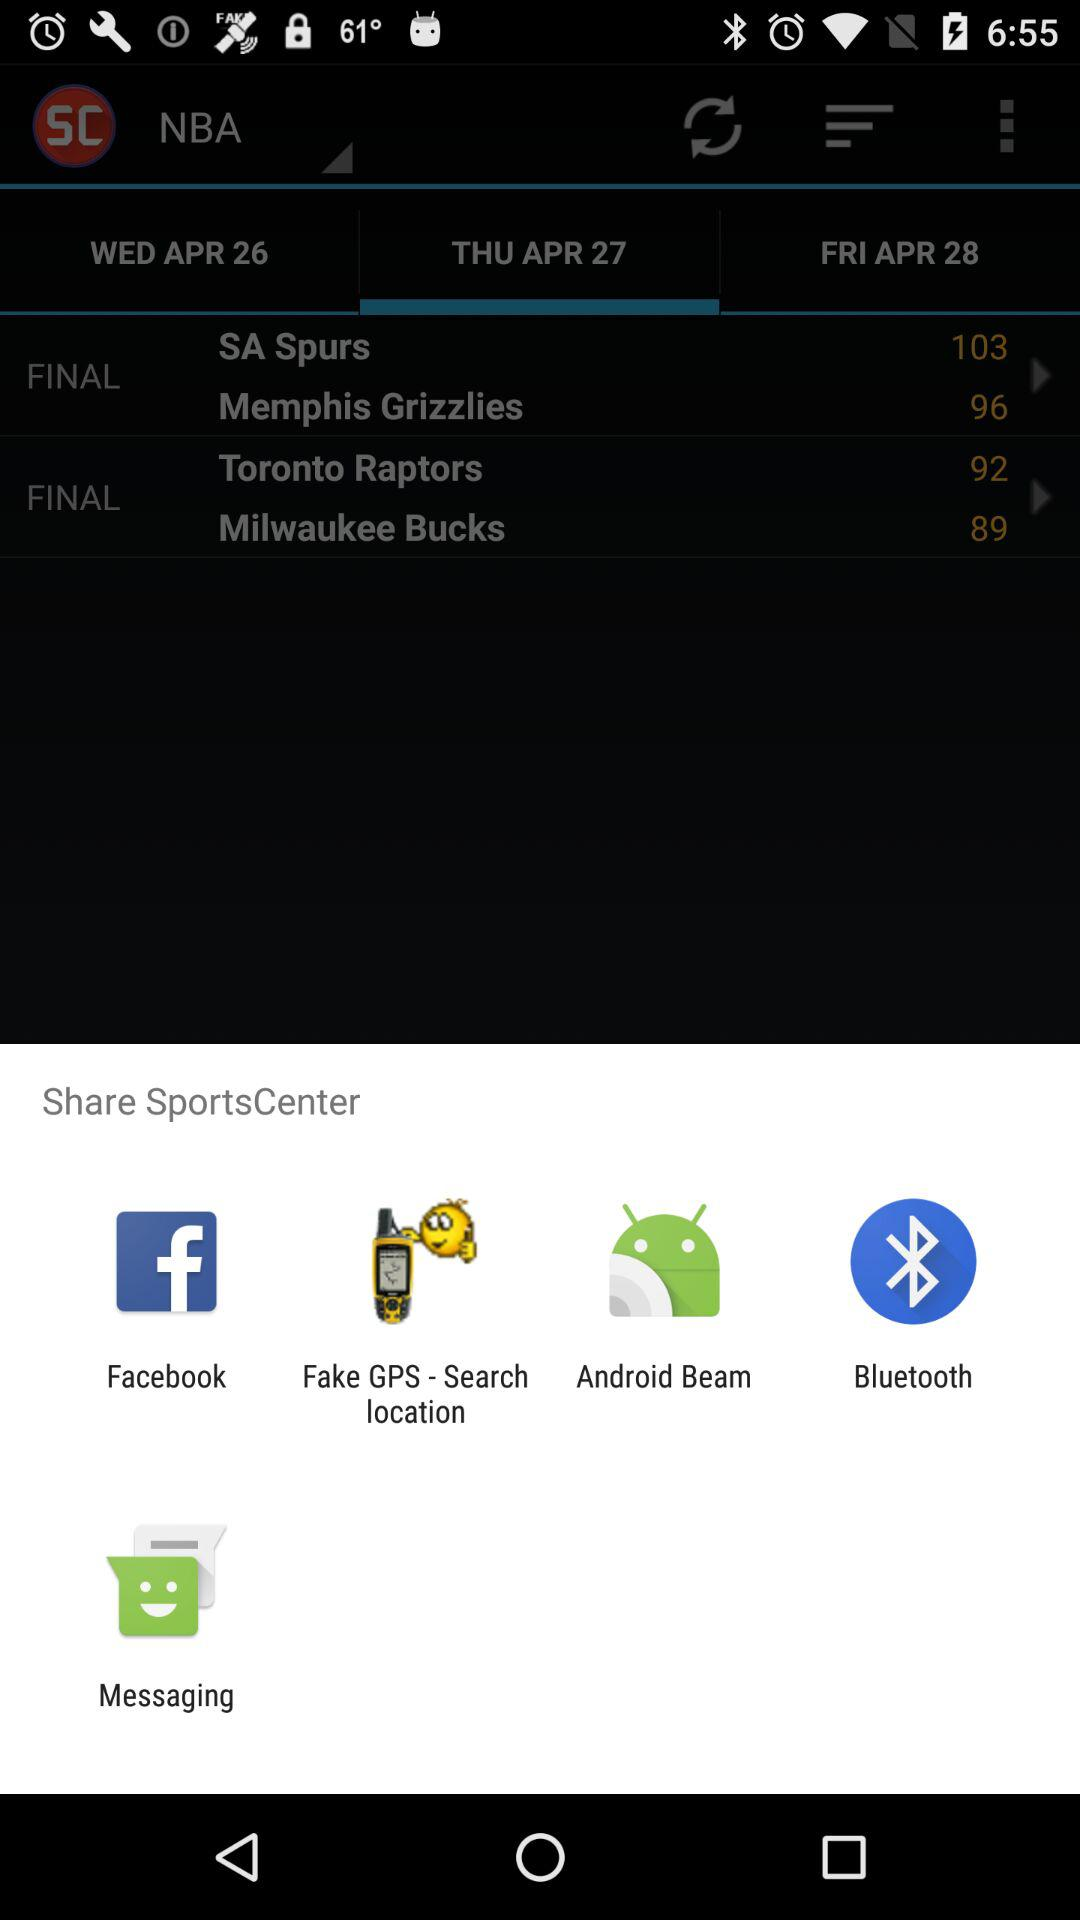What are the options to share? The options are "Facebook", "Fake GPS - Search location", "Android Beam", "Bluetooth" and "Messaging". 